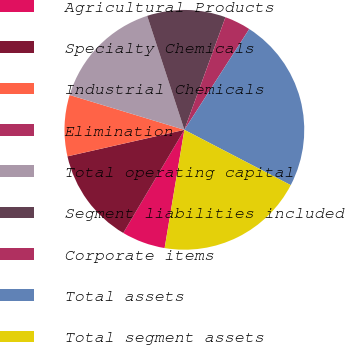Convert chart to OTSL. <chart><loc_0><loc_0><loc_500><loc_500><pie_chart><fcel>Agricultural Products<fcel>Specialty Chemicals<fcel>Industrial Chemicals<fcel>Elimination<fcel>Total operating capital<fcel>Segment liabilities included<fcel>Corporate items<fcel>Total assets<fcel>Total segment assets<nl><fcel>5.88%<fcel>12.94%<fcel>8.24%<fcel>0.0%<fcel>15.29%<fcel>10.59%<fcel>3.53%<fcel>23.53%<fcel>20.0%<nl></chart> 